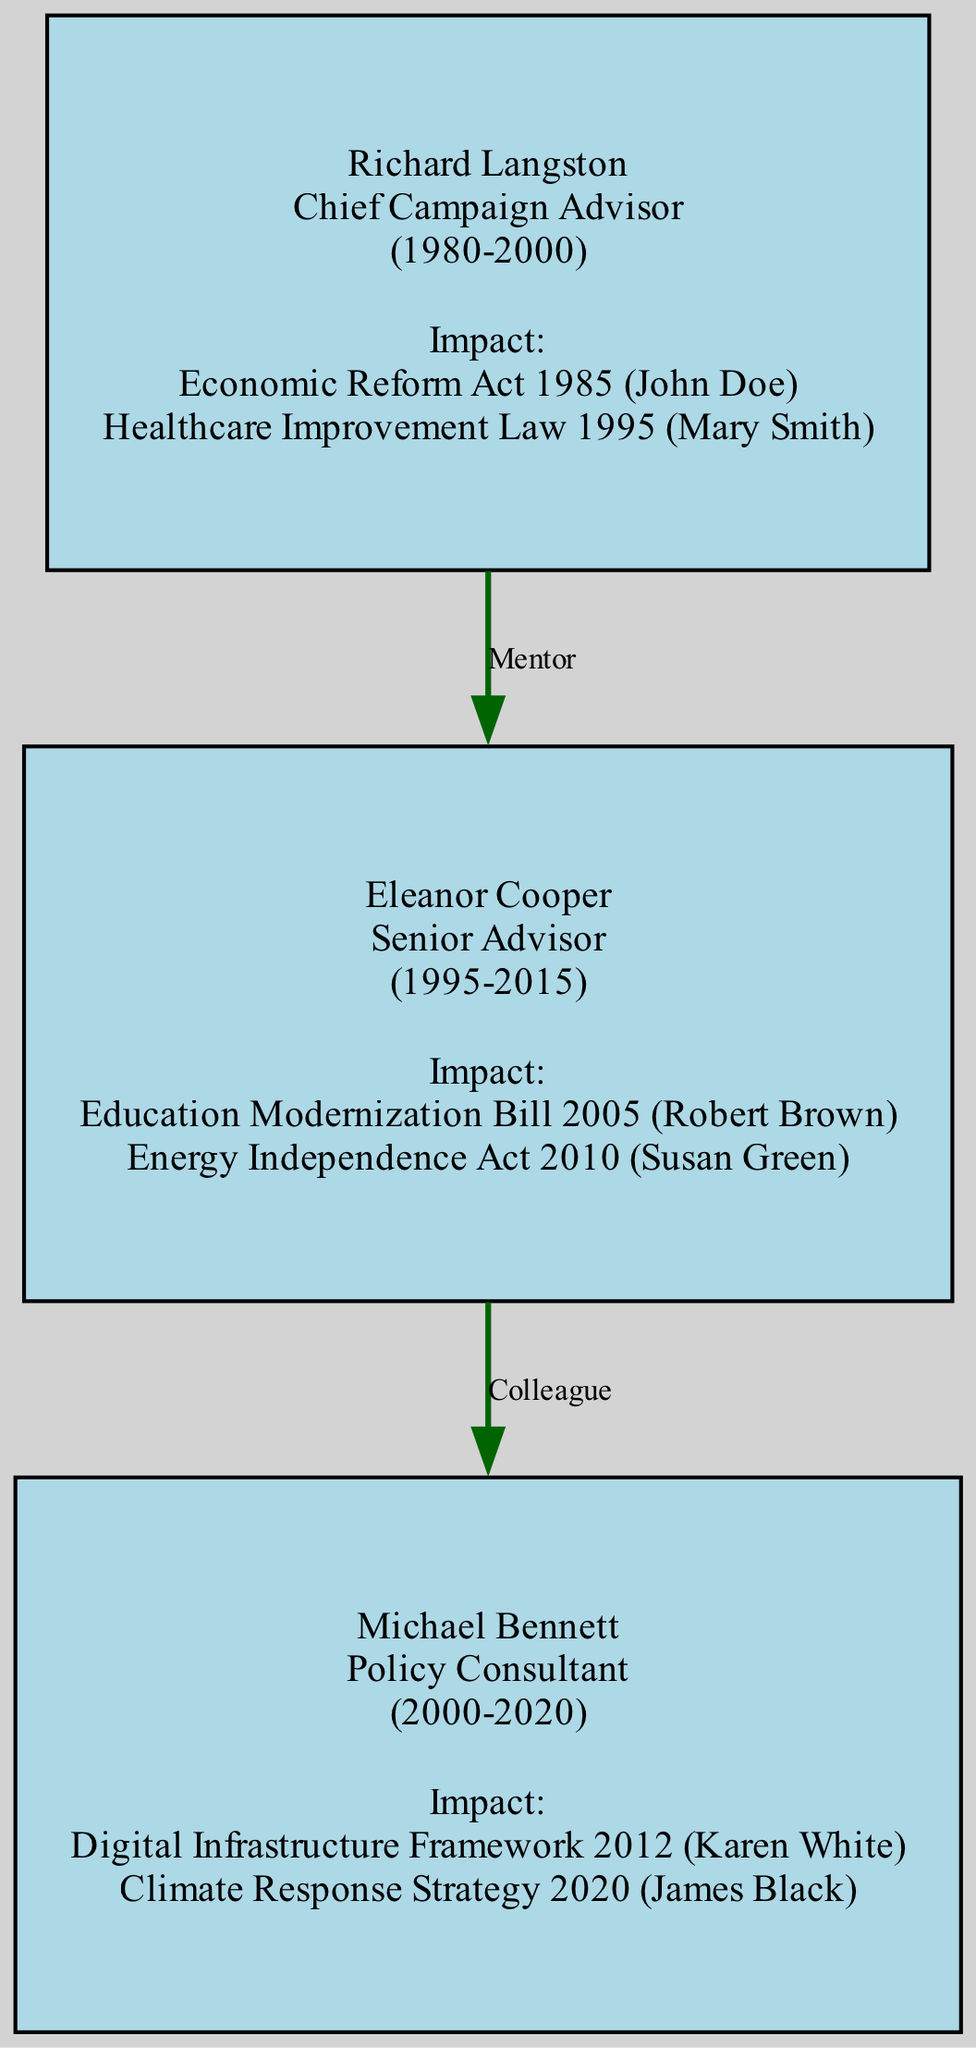What is the total number of nodes in the diagram? The diagram displays three individuals as nodes in the family tree: Richard Langston, Eleanor Cooper, and Michael Bennett. By counting each of them, we find that there are 3 nodes in total.
Answer: 3 Who is the Chief Campaign Advisor? The node labeled with the role "Chief Campaign Advisor" corresponds to Richard Langston, who holds this specific title in the diagram.
Answer: Richard Langston What relationship exists between Richard Langston and Eleanor Cooper? The diagram specifies a link between Richard Langston and Eleanor Cooper marked as "Mentor," indicating that Richard provided guidance or support to Eleanor in her role.
Answer: Mentor Which policy did Eleanor Cooper influence? When reviewing Eleanor Cooper's impacts, we identify the "Education Modernization Bill 2005" as one of the policies she influenced according to the information in her node.
Answer: Education Modernization Bill 2005 Which parliament member did Michael Bennett work with on the Climate Response Strategy? To answer this, we look at the impact section of Michael Bennett’s node and find that he worked on the "Climate Response Strategy 2020" specifically with James Black, as indicated in his impact details.
Answer: James Black How many policies did Richard Langston impact? By examining the list of impacts associated with Richard Langston, we see that there are two policies: "Economic Reform Act 1985" and "Healthcare Improvement Law 1995." Therefore, the total is 2.
Answer: 2 What is the role of Michael Bennett in the diagram? The role assigned to the node of Michael Bennett clearly states that he is a "Policy Consultant," and this information is directly available from the diagram's representation of this node.
Answer: Policy Consultant Who were Eleanor Cooper's colleagues? When looking at the connections, it’s observed that Eleanor Cooper worked alongside Michael Bennett, which is highlighted by the "Colleague" relationship linking the two nodes.
Answer: Michael Bennett What was the earliest active year for Richard Langston? The diagram specifies that Richard Langston was active from 1980, which is reflected in the "years_active" section within his node.
Answer: 1980 